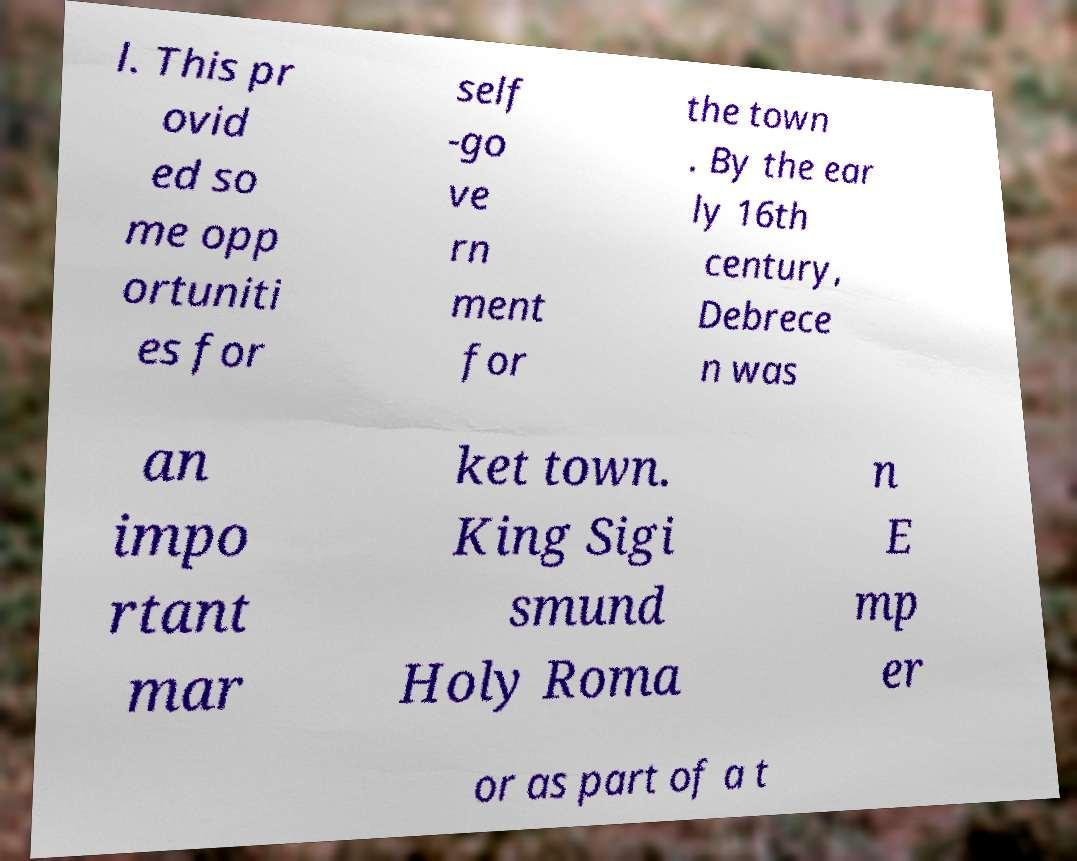Can you accurately transcribe the text from the provided image for me? l. This pr ovid ed so me opp ortuniti es for self -go ve rn ment for the town . By the ear ly 16th century, Debrece n was an impo rtant mar ket town. King Sigi smund Holy Roma n E mp er or as part of a t 